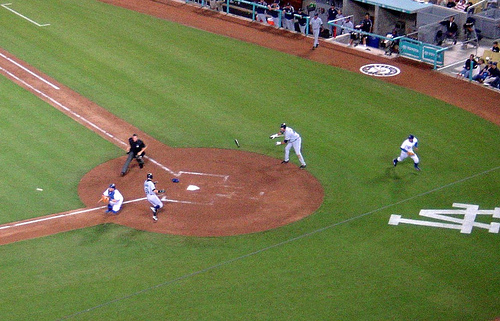<image>
Is there a paint on the grass? Yes. Looking at the image, I can see the paint is positioned on top of the grass, with the grass providing support. 